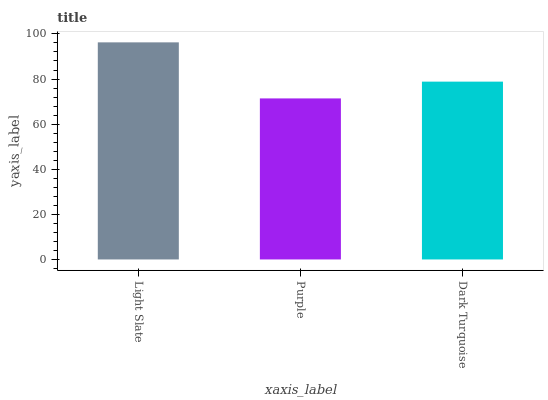Is Purple the minimum?
Answer yes or no. Yes. Is Light Slate the maximum?
Answer yes or no. Yes. Is Dark Turquoise the minimum?
Answer yes or no. No. Is Dark Turquoise the maximum?
Answer yes or no. No. Is Dark Turquoise greater than Purple?
Answer yes or no. Yes. Is Purple less than Dark Turquoise?
Answer yes or no. Yes. Is Purple greater than Dark Turquoise?
Answer yes or no. No. Is Dark Turquoise less than Purple?
Answer yes or no. No. Is Dark Turquoise the high median?
Answer yes or no. Yes. Is Dark Turquoise the low median?
Answer yes or no. Yes. Is Purple the high median?
Answer yes or no. No. Is Purple the low median?
Answer yes or no. No. 